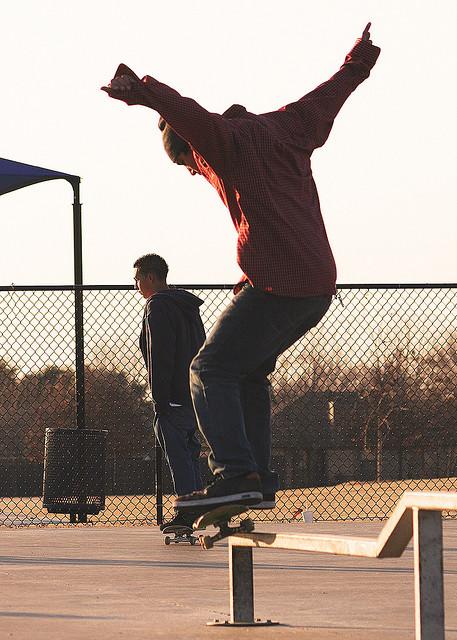What is the fence made from?
Answer briefly. Metal. Is there a bike?
Short answer required. No. What is he on?
Answer briefly. Skateboard. Is he grinding the rail?
Write a very short answer. Yes. 